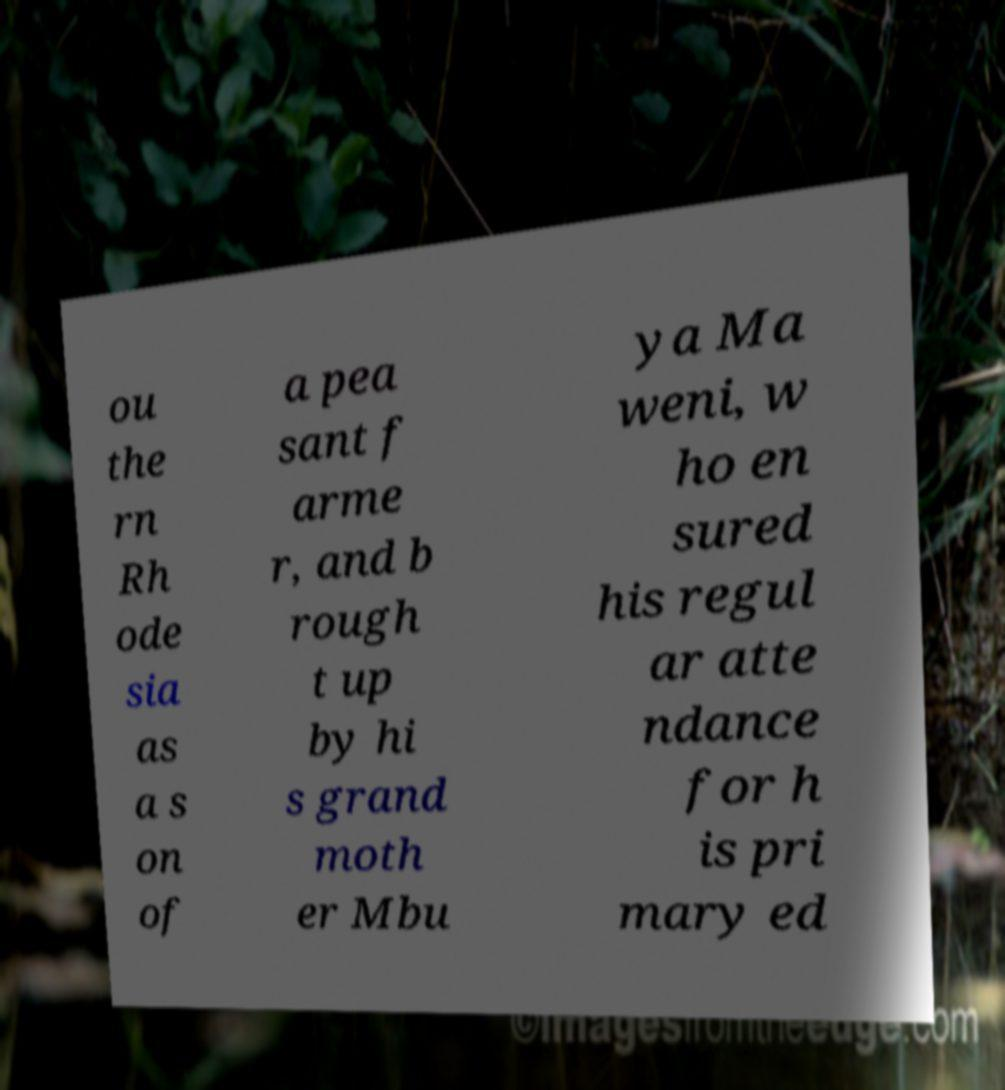Please read and relay the text visible in this image. What does it say? ou the rn Rh ode sia as a s on of a pea sant f arme r, and b rough t up by hi s grand moth er Mbu ya Ma weni, w ho en sured his regul ar atte ndance for h is pri mary ed 